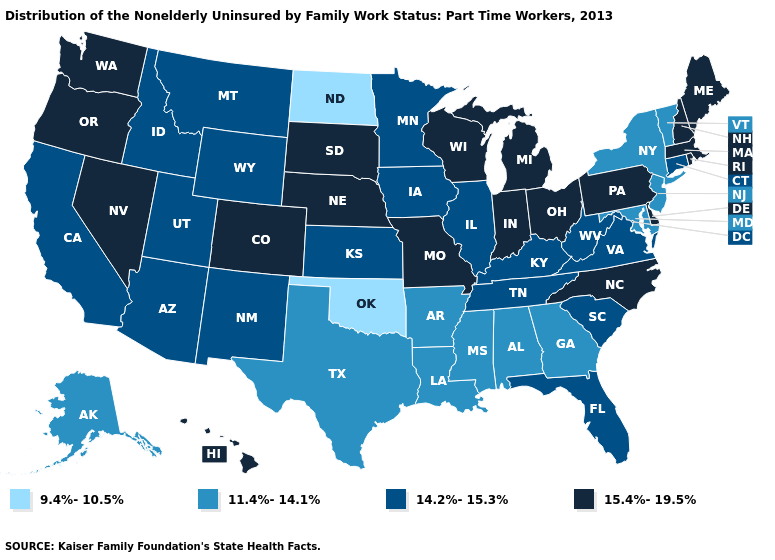Does the map have missing data?
Quick response, please. No. What is the value of Kentucky?
Quick response, please. 14.2%-15.3%. Does New Hampshire have a higher value than North Dakota?
Short answer required. Yes. Among the states that border Washington , which have the highest value?
Concise answer only. Oregon. Name the states that have a value in the range 15.4%-19.5%?
Short answer required. Colorado, Delaware, Hawaii, Indiana, Maine, Massachusetts, Michigan, Missouri, Nebraska, Nevada, New Hampshire, North Carolina, Ohio, Oregon, Pennsylvania, Rhode Island, South Dakota, Washington, Wisconsin. What is the value of Maine?
Quick response, please. 15.4%-19.5%. Does Vermont have the highest value in the Northeast?
Give a very brief answer. No. Does West Virginia have the highest value in the USA?
Keep it brief. No. What is the highest value in the Northeast ?
Be succinct. 15.4%-19.5%. Among the states that border Nebraska , does Missouri have the highest value?
Write a very short answer. Yes. Does Montana have the same value as Texas?
Give a very brief answer. No. What is the highest value in states that border South Carolina?
Short answer required. 15.4%-19.5%. Does Rhode Island have a higher value than Michigan?
Be succinct. No. Does North Dakota have the lowest value in the MidWest?
Give a very brief answer. Yes. What is the highest value in states that border Missouri?
Write a very short answer. 15.4%-19.5%. 